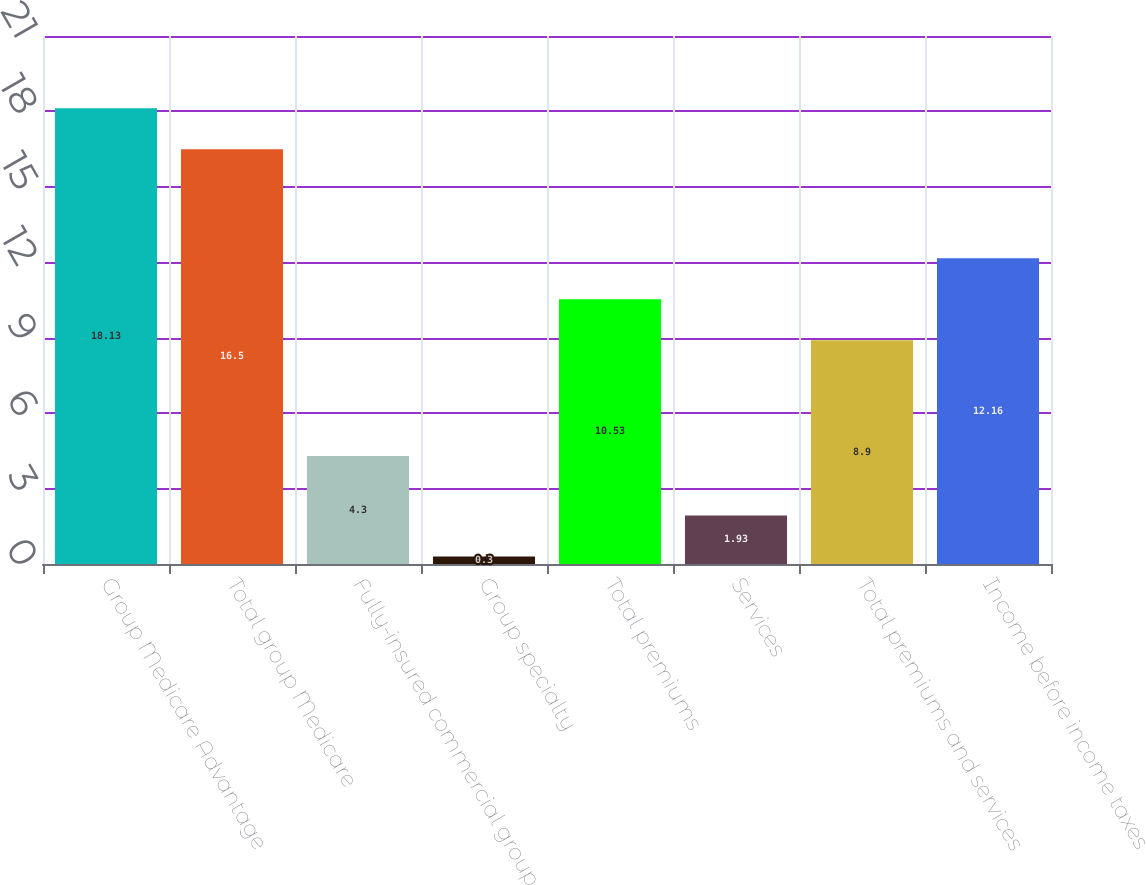<chart> <loc_0><loc_0><loc_500><loc_500><bar_chart><fcel>Group Medicare Advantage<fcel>Total group Medicare<fcel>Fully-insured commercial group<fcel>Group specialty<fcel>Total premiums<fcel>Services<fcel>Total premiums and services<fcel>Income before income taxes<nl><fcel>18.13<fcel>16.5<fcel>4.3<fcel>0.3<fcel>10.53<fcel>1.93<fcel>8.9<fcel>12.16<nl></chart> 